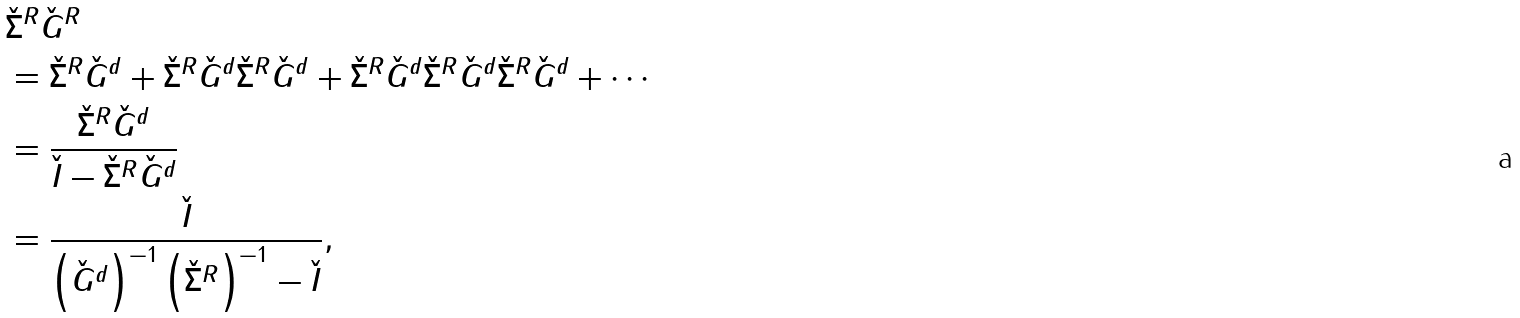<formula> <loc_0><loc_0><loc_500><loc_500>& \check { \Sigma } ^ { R } \check { G } ^ { R } \\ & = \check { \Sigma } ^ { R } \check { G } ^ { d } + \check { \Sigma } ^ { R } \check { G } ^ { d } \check { \Sigma } ^ { R } \check { G } ^ { d } + \check { \Sigma } ^ { R } \check { G } ^ { d } \check { \Sigma } ^ { R } \check { G } ^ { d } \check { \Sigma } ^ { R } \check { G } ^ { d } + \cdots \\ & = \frac { \check { \Sigma } ^ { R } \check { G } ^ { d } } { \check { I } - \check { \Sigma } ^ { R } \check { G } ^ { d } } \\ & = \frac { \check { I } } { \left ( \check { G } ^ { d } \right ) ^ { - 1 } \left ( \check { \Sigma } ^ { R } \right ) ^ { - 1 } - \check { I } } ,</formula> 